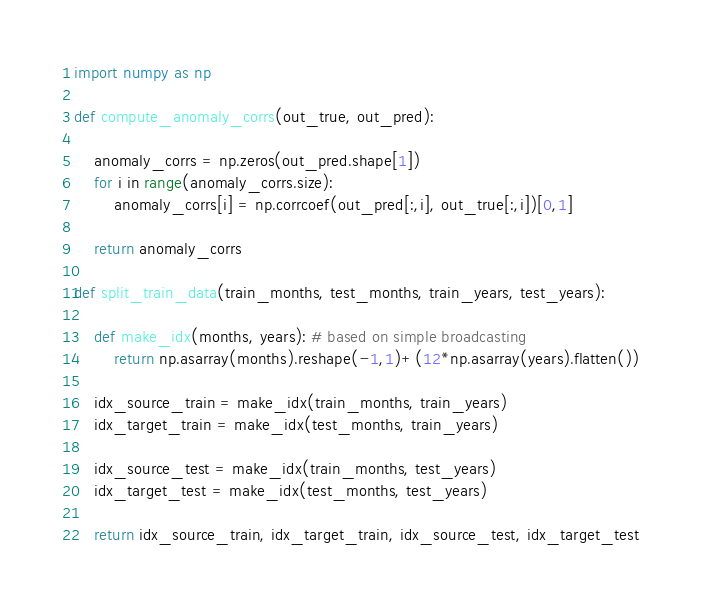Convert code to text. <code><loc_0><loc_0><loc_500><loc_500><_Python_>import numpy as np

def compute_anomaly_corrs(out_true, out_pred):
    
    anomaly_corrs = np.zeros(out_pred.shape[1])
    for i in range(anomaly_corrs.size):
        anomaly_corrs[i] = np.corrcoef(out_pred[:,i], out_true[:,i])[0,1]
        
    return anomaly_corrs

def split_train_data(train_months, test_months, train_years, test_years):

    def make_idx(months, years): # based on simple broadcasting
        return np.asarray(months).reshape(-1,1)+(12*np.asarray(years).flatten())

    idx_source_train = make_idx(train_months, train_years)
    idx_target_train = make_idx(test_months, train_years)

    idx_source_test = make_idx(train_months, test_years)
    idx_target_test = make_idx(test_months, test_years)

    return idx_source_train, idx_target_train, idx_source_test, idx_target_test</code> 